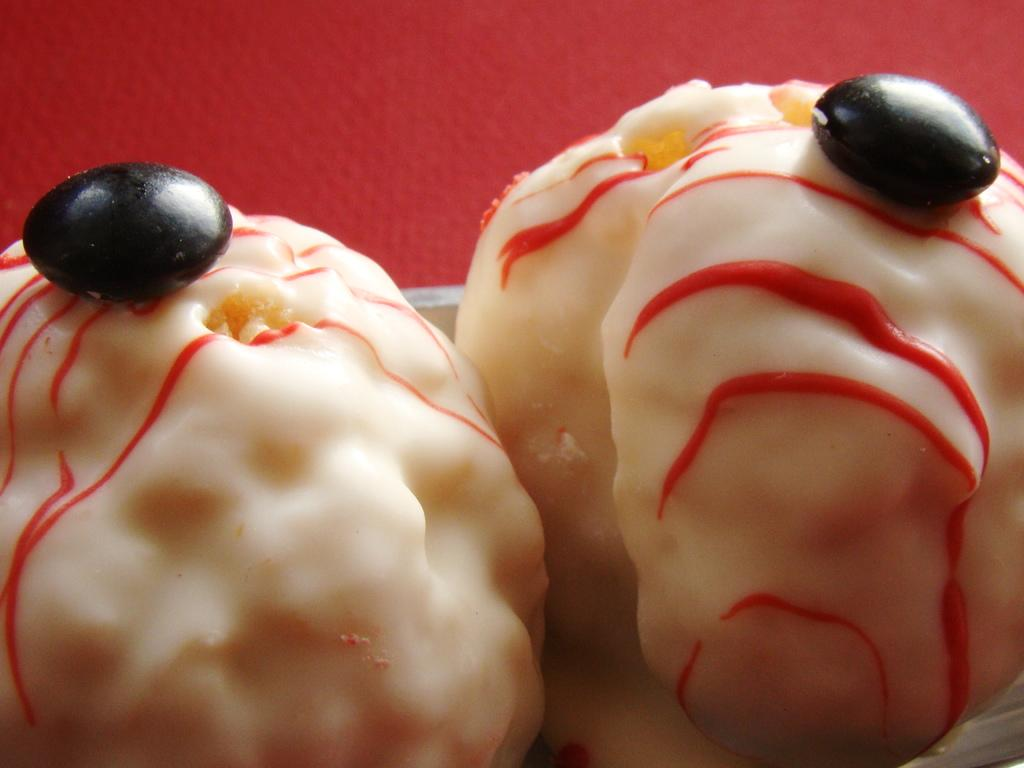What is the main subject of the image? There is a food item in the center of the image. What color is the background of the image? The background of the image is red in color. What direction is the oven facing in the image? There is no oven present in the image. Is the alley visible in the image? There is no alley present in the image. 